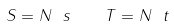Convert formula to latex. <formula><loc_0><loc_0><loc_500><loc_500>S = N \ s \quad T = N \ t</formula> 